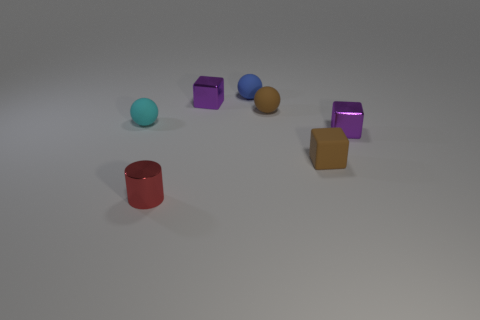How many purple blocks must be subtracted to get 1 purple blocks? 1 Subtract 1 spheres. How many spheres are left? 2 Add 2 red metal cylinders. How many objects exist? 9 Subtract all cylinders. How many objects are left? 6 Subtract 1 purple blocks. How many objects are left? 6 Subtract all matte blocks. Subtract all blue matte objects. How many objects are left? 5 Add 1 tiny purple shiny blocks. How many tiny purple shiny blocks are left? 3 Add 1 small purple cubes. How many small purple cubes exist? 3 